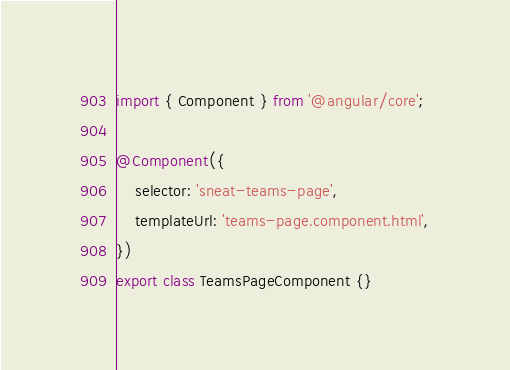Convert code to text. <code><loc_0><loc_0><loc_500><loc_500><_TypeScript_>import { Component } from '@angular/core';

@Component({
	selector: 'sneat-teams-page',
	templateUrl: 'teams-page.component.html',
})
export class TeamsPageComponent {}
</code> 